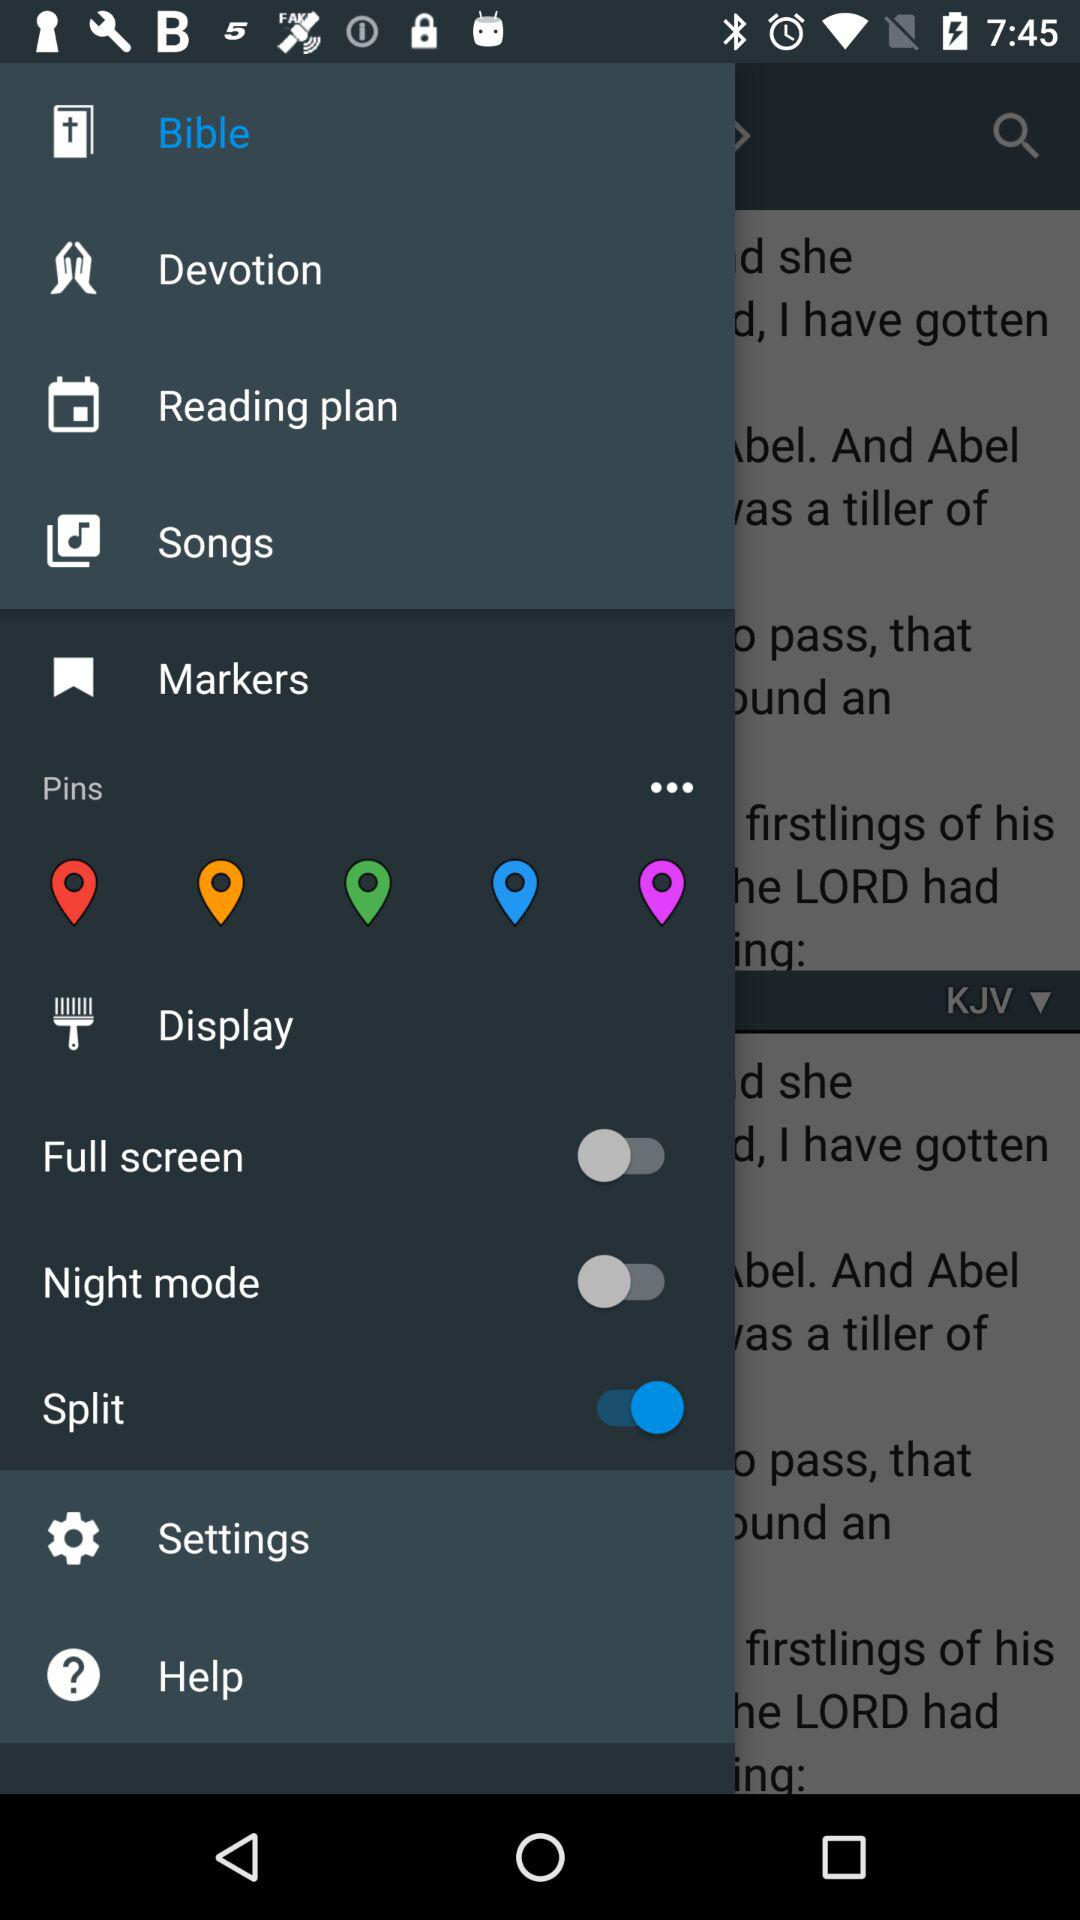What is the status of the split? The status is on. 